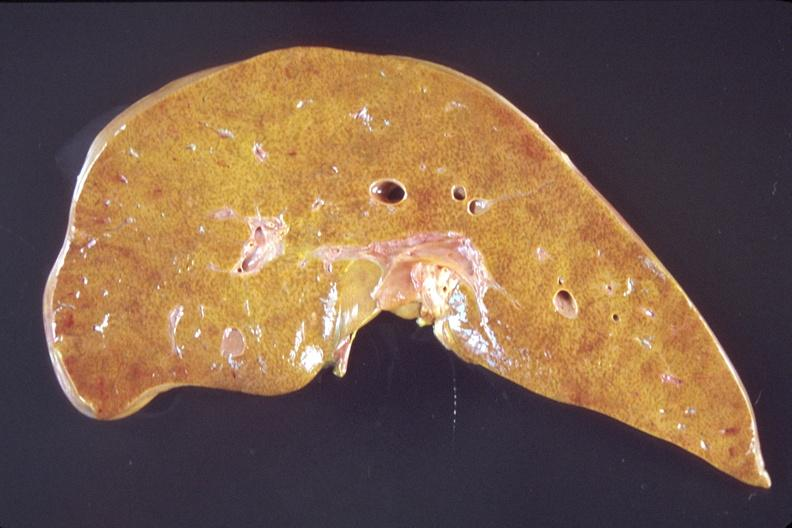s close-up excellent example of interosseous muscle atrophy present?
Answer the question using a single word or phrase. No 